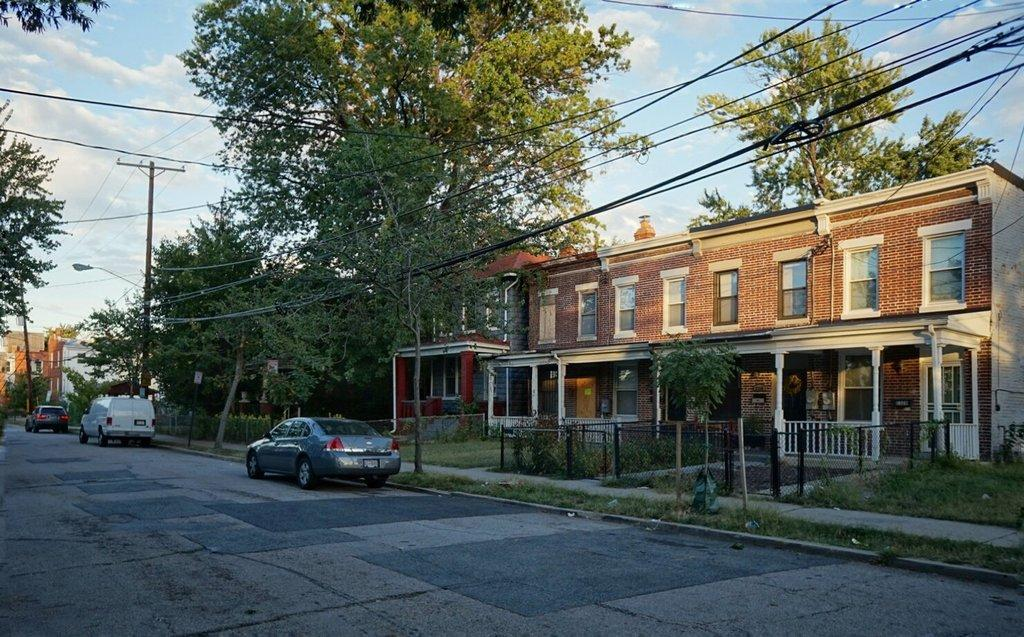What can be seen on the road in the image? There are cars parked on the road in the image. What structures are visible in the image? There are buildings visible in the image. What type of vegetation is present in the image? There are trees in the image. What additional infrastructure can be seen in the image? There are electrical light pole wires in the image. Where is the toothpaste located in the image? There is no toothpaste present in the image. What type of tree is depicted in the image? The provided facts do not specify the type of tree; only that there are trees in the image. How many sheep are visible in the image? There are no sheep present in the image. 